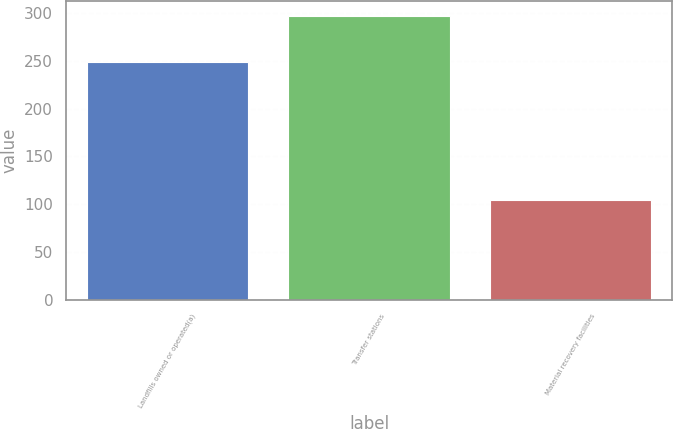<chart> <loc_0><loc_0><loc_500><loc_500><bar_chart><fcel>Landfills owned or operated(a)<fcel>Transfer stations<fcel>Material recovery facilities<nl><fcel>249<fcel>297<fcel>104<nl></chart> 